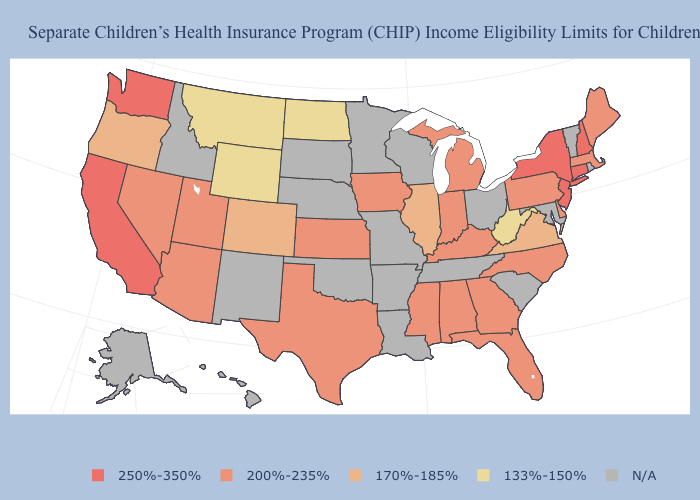Among the states that border West Virginia , which have the lowest value?
Give a very brief answer. Virginia. Which states hav the highest value in the West?
Write a very short answer. California, Washington. Does the first symbol in the legend represent the smallest category?
Keep it brief. No. Name the states that have a value in the range 200%-235%?
Answer briefly. Alabama, Arizona, Delaware, Florida, Georgia, Indiana, Iowa, Kansas, Kentucky, Maine, Massachusetts, Michigan, Mississippi, Nevada, North Carolina, Pennsylvania, Texas, Utah. What is the value of Delaware?
Give a very brief answer. 200%-235%. Does Florida have the lowest value in the South?
Quick response, please. No. What is the value of North Dakota?
Keep it brief. 133%-150%. Does New Hampshire have the lowest value in the Northeast?
Be succinct. No. Which states have the highest value in the USA?
Short answer required. California, Connecticut, New Hampshire, New Jersey, New York, Washington. Name the states that have a value in the range 133%-150%?
Write a very short answer. Montana, North Dakota, West Virginia, Wyoming. Which states hav the highest value in the Northeast?
Quick response, please. Connecticut, New Hampshire, New Jersey, New York. What is the value of Kansas?
Give a very brief answer. 200%-235%. What is the value of Arkansas?
Answer briefly. N/A. Name the states that have a value in the range 170%-185%?
Keep it brief. Colorado, Illinois, Oregon, Virginia. 